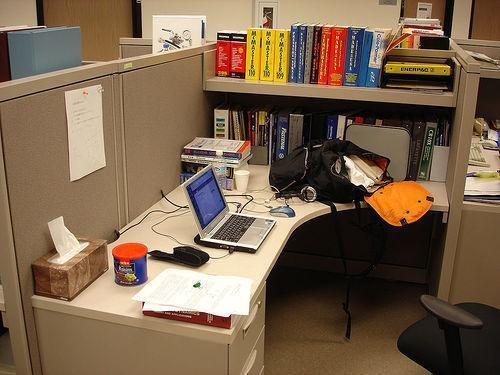How many laptops are there?
Give a very brief answer. 1. 